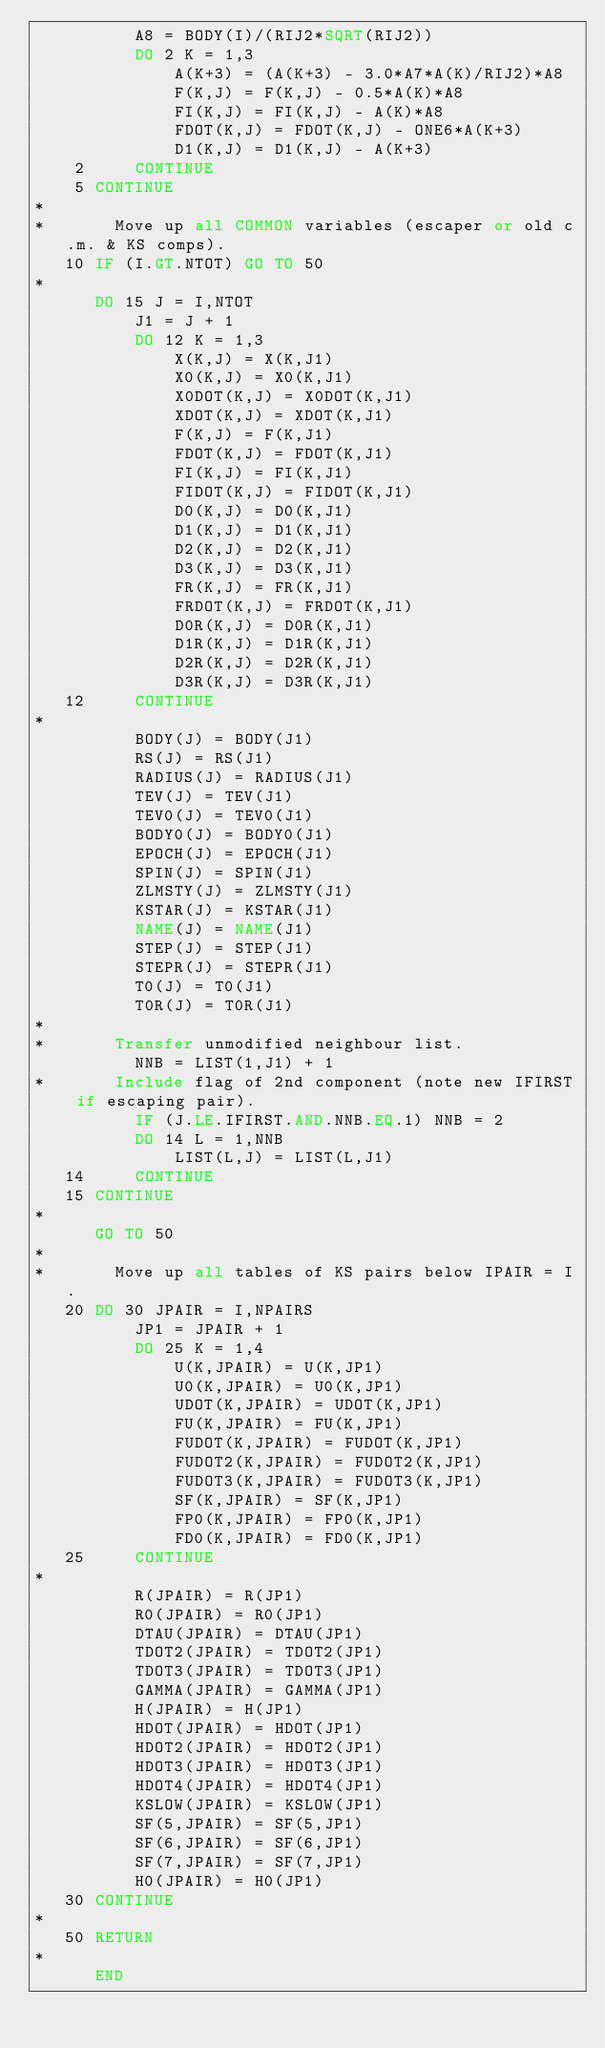Convert code to text. <code><loc_0><loc_0><loc_500><loc_500><_FORTRAN_>          A8 = BODY(I)/(RIJ2*SQRT(RIJ2))
          DO 2 K = 1,3
              A(K+3) = (A(K+3) - 3.0*A7*A(K)/RIJ2)*A8
              F(K,J) = F(K,J) - 0.5*A(K)*A8
              FI(K,J) = FI(K,J) - A(K)*A8
              FDOT(K,J) = FDOT(K,J) - ONE6*A(K+3)
              D1(K,J) = D1(K,J) - A(K+3)
    2     CONTINUE
    5 CONTINUE
*
*       Move up all COMMON variables (escaper or old c.m. & KS comps).
   10 IF (I.GT.NTOT) GO TO 50
*
      DO 15 J = I,NTOT
          J1 = J + 1
          DO 12 K = 1,3
              X(K,J) = X(K,J1)
              X0(K,J) = X0(K,J1)
              X0DOT(K,J) = X0DOT(K,J1)
              XDOT(K,J) = XDOT(K,J1)
              F(K,J) = F(K,J1)
              FDOT(K,J) = FDOT(K,J1)
              FI(K,J) = FI(K,J1)
              FIDOT(K,J) = FIDOT(K,J1)
              D0(K,J) = D0(K,J1)
              D1(K,J) = D1(K,J1)
              D2(K,J) = D2(K,J1)
              D3(K,J) = D3(K,J1)
              FR(K,J) = FR(K,J1)
              FRDOT(K,J) = FRDOT(K,J1)
              D0R(K,J) = D0R(K,J1)
              D1R(K,J) = D1R(K,J1)
              D2R(K,J) = D2R(K,J1)
              D3R(K,J) = D3R(K,J1)
   12     CONTINUE
*
          BODY(J) = BODY(J1)
          RS(J) = RS(J1)
          RADIUS(J) = RADIUS(J1)
          TEV(J) = TEV(J1)
          TEV0(J) = TEV0(J1)
          BODY0(J) = BODY0(J1)
          EPOCH(J) = EPOCH(J1)
          SPIN(J) = SPIN(J1)
          ZLMSTY(J) = ZLMSTY(J1)
          KSTAR(J) = KSTAR(J1)
          NAME(J) = NAME(J1)
          STEP(J) = STEP(J1)
          STEPR(J) = STEPR(J1)
          T0(J) = T0(J1)
          T0R(J) = T0R(J1)
*
*       Transfer unmodified neighbour list.
          NNB = LIST(1,J1) + 1
*       Include flag of 2nd component (note new IFIRST if escaping pair).
          IF (J.LE.IFIRST.AND.NNB.EQ.1) NNB = 2
          DO 14 L = 1,NNB
              LIST(L,J) = LIST(L,J1)
   14     CONTINUE
   15 CONTINUE
*
      GO TO 50
*
*       Move up all tables of KS pairs below IPAIR = I.
   20 DO 30 JPAIR = I,NPAIRS
          JP1 = JPAIR + 1
          DO 25 K = 1,4
              U(K,JPAIR) = U(K,JP1)
              U0(K,JPAIR) = U0(K,JP1)
              UDOT(K,JPAIR) = UDOT(K,JP1)
              FU(K,JPAIR) = FU(K,JP1)
              FUDOT(K,JPAIR) = FUDOT(K,JP1)
              FUDOT2(K,JPAIR) = FUDOT2(K,JP1)
              FUDOT3(K,JPAIR) = FUDOT3(K,JP1)
              SF(K,JPAIR) = SF(K,JP1)
              FP0(K,JPAIR) = FP0(K,JP1)
              FD0(K,JPAIR) = FD0(K,JP1)
   25     CONTINUE
*
          R(JPAIR) = R(JP1)
          R0(JPAIR) = R0(JP1)
          DTAU(JPAIR) = DTAU(JP1)
          TDOT2(JPAIR) = TDOT2(JP1)
          TDOT3(JPAIR) = TDOT3(JP1)
          GAMMA(JPAIR) = GAMMA(JP1)
          H(JPAIR) = H(JP1)
          HDOT(JPAIR) = HDOT(JP1)
          HDOT2(JPAIR) = HDOT2(JP1)
          HDOT3(JPAIR) = HDOT3(JP1)
          HDOT4(JPAIR) = HDOT4(JP1)
          KSLOW(JPAIR) = KSLOW(JP1)
          SF(5,JPAIR) = SF(5,JP1)
          SF(6,JPAIR) = SF(6,JP1)
          SF(7,JPAIR) = SF(7,JP1)
          H0(JPAIR) = H0(JP1)
   30 CONTINUE
*
   50 RETURN
*
      END
</code> 